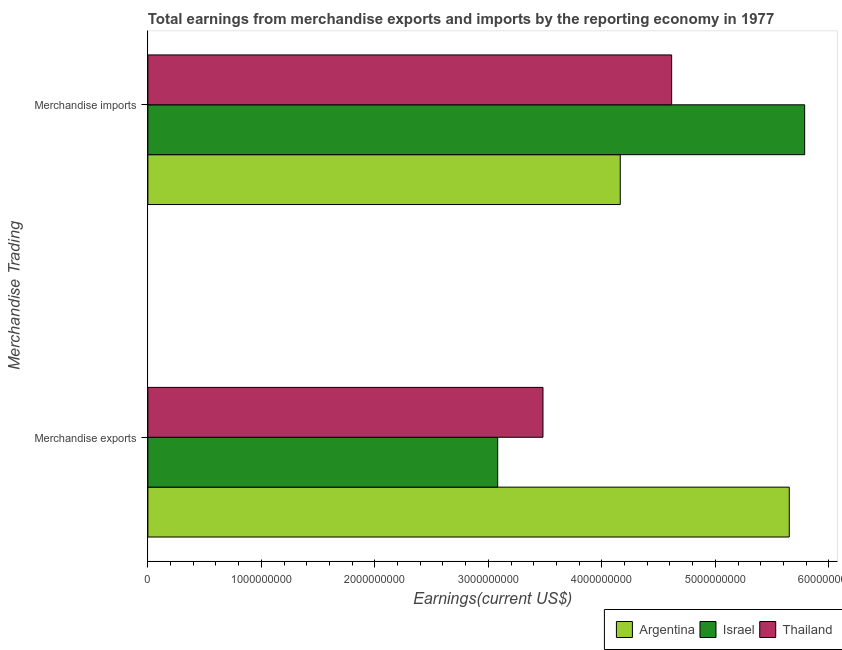How many different coloured bars are there?
Offer a terse response. 3. How many groups of bars are there?
Give a very brief answer. 2. What is the earnings from merchandise imports in Argentina?
Offer a very short reply. 4.16e+09. Across all countries, what is the maximum earnings from merchandise exports?
Make the answer very short. 5.65e+09. Across all countries, what is the minimum earnings from merchandise exports?
Your answer should be compact. 3.08e+09. In which country was the earnings from merchandise imports maximum?
Make the answer very short. Israel. What is the total earnings from merchandise exports in the graph?
Give a very brief answer. 1.22e+1. What is the difference between the earnings from merchandise imports in Thailand and that in Israel?
Make the answer very short. -1.17e+09. What is the difference between the earnings from merchandise exports in Israel and the earnings from merchandise imports in Thailand?
Your answer should be compact. -1.53e+09. What is the average earnings from merchandise imports per country?
Give a very brief answer. 4.86e+09. What is the difference between the earnings from merchandise exports and earnings from merchandise imports in Argentina?
Provide a succinct answer. 1.49e+09. In how many countries, is the earnings from merchandise exports greater than 5400000000 US$?
Your answer should be very brief. 1. What is the ratio of the earnings from merchandise exports in Israel to that in Thailand?
Your answer should be compact. 0.89. Is the earnings from merchandise exports in Argentina less than that in Israel?
Ensure brevity in your answer.  No. In how many countries, is the earnings from merchandise imports greater than the average earnings from merchandise imports taken over all countries?
Offer a terse response. 1. What does the 2nd bar from the top in Merchandise exports represents?
Give a very brief answer. Israel. What does the 1st bar from the bottom in Merchandise imports represents?
Offer a terse response. Argentina. How many bars are there?
Make the answer very short. 6. Are all the bars in the graph horizontal?
Your answer should be very brief. Yes. How many countries are there in the graph?
Ensure brevity in your answer.  3. What is the difference between two consecutive major ticks on the X-axis?
Offer a very short reply. 1.00e+09. Are the values on the major ticks of X-axis written in scientific E-notation?
Your answer should be compact. No. Where does the legend appear in the graph?
Give a very brief answer. Bottom right. How are the legend labels stacked?
Your response must be concise. Horizontal. What is the title of the graph?
Your response must be concise. Total earnings from merchandise exports and imports by the reporting economy in 1977. Does "Samoa" appear as one of the legend labels in the graph?
Offer a very short reply. No. What is the label or title of the X-axis?
Keep it short and to the point. Earnings(current US$). What is the label or title of the Y-axis?
Provide a succinct answer. Merchandise Trading. What is the Earnings(current US$) in Argentina in Merchandise exports?
Ensure brevity in your answer.  5.65e+09. What is the Earnings(current US$) in Israel in Merchandise exports?
Your response must be concise. 3.08e+09. What is the Earnings(current US$) in Thailand in Merchandise exports?
Ensure brevity in your answer.  3.48e+09. What is the Earnings(current US$) in Argentina in Merchandise imports?
Your answer should be very brief. 4.16e+09. What is the Earnings(current US$) of Israel in Merchandise imports?
Give a very brief answer. 5.79e+09. What is the Earnings(current US$) of Thailand in Merchandise imports?
Give a very brief answer. 4.62e+09. Across all Merchandise Trading, what is the maximum Earnings(current US$) of Argentina?
Provide a short and direct response. 5.65e+09. Across all Merchandise Trading, what is the maximum Earnings(current US$) of Israel?
Ensure brevity in your answer.  5.79e+09. Across all Merchandise Trading, what is the maximum Earnings(current US$) in Thailand?
Your answer should be compact. 4.62e+09. Across all Merchandise Trading, what is the minimum Earnings(current US$) of Argentina?
Ensure brevity in your answer.  4.16e+09. Across all Merchandise Trading, what is the minimum Earnings(current US$) of Israel?
Offer a terse response. 3.08e+09. Across all Merchandise Trading, what is the minimum Earnings(current US$) of Thailand?
Give a very brief answer. 3.48e+09. What is the total Earnings(current US$) of Argentina in the graph?
Your answer should be very brief. 9.81e+09. What is the total Earnings(current US$) of Israel in the graph?
Offer a very short reply. 8.87e+09. What is the total Earnings(current US$) of Thailand in the graph?
Offer a terse response. 8.10e+09. What is the difference between the Earnings(current US$) in Argentina in Merchandise exports and that in Merchandise imports?
Your response must be concise. 1.49e+09. What is the difference between the Earnings(current US$) of Israel in Merchandise exports and that in Merchandise imports?
Keep it short and to the point. -2.70e+09. What is the difference between the Earnings(current US$) of Thailand in Merchandise exports and that in Merchandise imports?
Your answer should be very brief. -1.13e+09. What is the difference between the Earnings(current US$) of Argentina in Merchandise exports and the Earnings(current US$) of Israel in Merchandise imports?
Provide a succinct answer. -1.36e+08. What is the difference between the Earnings(current US$) in Argentina in Merchandise exports and the Earnings(current US$) in Thailand in Merchandise imports?
Your answer should be very brief. 1.04e+09. What is the difference between the Earnings(current US$) of Israel in Merchandise exports and the Earnings(current US$) of Thailand in Merchandise imports?
Provide a short and direct response. -1.53e+09. What is the average Earnings(current US$) in Argentina per Merchandise Trading?
Keep it short and to the point. 4.91e+09. What is the average Earnings(current US$) in Israel per Merchandise Trading?
Give a very brief answer. 4.43e+09. What is the average Earnings(current US$) in Thailand per Merchandise Trading?
Your response must be concise. 4.05e+09. What is the difference between the Earnings(current US$) of Argentina and Earnings(current US$) of Israel in Merchandise exports?
Make the answer very short. 2.57e+09. What is the difference between the Earnings(current US$) of Argentina and Earnings(current US$) of Thailand in Merchandise exports?
Offer a terse response. 2.17e+09. What is the difference between the Earnings(current US$) of Israel and Earnings(current US$) of Thailand in Merchandise exports?
Your response must be concise. -3.99e+08. What is the difference between the Earnings(current US$) of Argentina and Earnings(current US$) of Israel in Merchandise imports?
Offer a very short reply. -1.62e+09. What is the difference between the Earnings(current US$) of Argentina and Earnings(current US$) of Thailand in Merchandise imports?
Give a very brief answer. -4.53e+08. What is the difference between the Earnings(current US$) of Israel and Earnings(current US$) of Thailand in Merchandise imports?
Make the answer very short. 1.17e+09. What is the ratio of the Earnings(current US$) in Argentina in Merchandise exports to that in Merchandise imports?
Provide a short and direct response. 1.36. What is the ratio of the Earnings(current US$) in Israel in Merchandise exports to that in Merchandise imports?
Your answer should be compact. 0.53. What is the ratio of the Earnings(current US$) of Thailand in Merchandise exports to that in Merchandise imports?
Provide a succinct answer. 0.75. What is the difference between the highest and the second highest Earnings(current US$) of Argentina?
Make the answer very short. 1.49e+09. What is the difference between the highest and the second highest Earnings(current US$) in Israel?
Your response must be concise. 2.70e+09. What is the difference between the highest and the second highest Earnings(current US$) in Thailand?
Provide a short and direct response. 1.13e+09. What is the difference between the highest and the lowest Earnings(current US$) of Argentina?
Your answer should be compact. 1.49e+09. What is the difference between the highest and the lowest Earnings(current US$) of Israel?
Your response must be concise. 2.70e+09. What is the difference between the highest and the lowest Earnings(current US$) of Thailand?
Make the answer very short. 1.13e+09. 